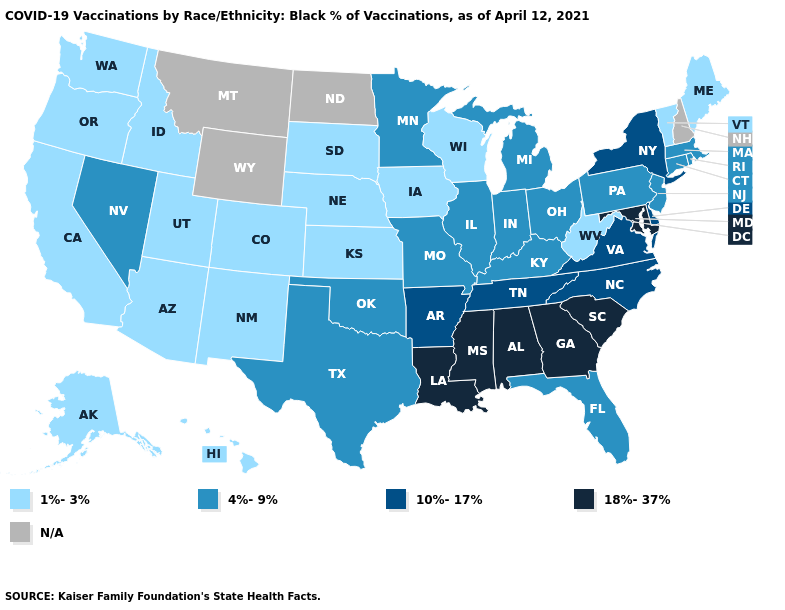Which states have the lowest value in the USA?
Be succinct. Alaska, Arizona, California, Colorado, Hawaii, Idaho, Iowa, Kansas, Maine, Nebraska, New Mexico, Oregon, South Dakota, Utah, Vermont, Washington, West Virginia, Wisconsin. What is the highest value in states that border Ohio?
Be succinct. 4%-9%. Does West Virginia have the lowest value in the South?
Write a very short answer. Yes. What is the lowest value in the USA?
Quick response, please. 1%-3%. What is the value of Alabama?
Concise answer only. 18%-37%. What is the lowest value in states that border Oklahoma?
Short answer required. 1%-3%. What is the highest value in the West ?
Short answer required. 4%-9%. Among the states that border Oregon , which have the highest value?
Short answer required. Nevada. What is the highest value in states that border Oklahoma?
Quick response, please. 10%-17%. Name the states that have a value in the range 18%-37%?
Short answer required. Alabama, Georgia, Louisiana, Maryland, Mississippi, South Carolina. Which states have the lowest value in the USA?
Write a very short answer. Alaska, Arizona, California, Colorado, Hawaii, Idaho, Iowa, Kansas, Maine, Nebraska, New Mexico, Oregon, South Dakota, Utah, Vermont, Washington, West Virginia, Wisconsin. Among the states that border North Carolina , does South Carolina have the lowest value?
Concise answer only. No. Which states hav the highest value in the South?
Concise answer only. Alabama, Georgia, Louisiana, Maryland, Mississippi, South Carolina. 